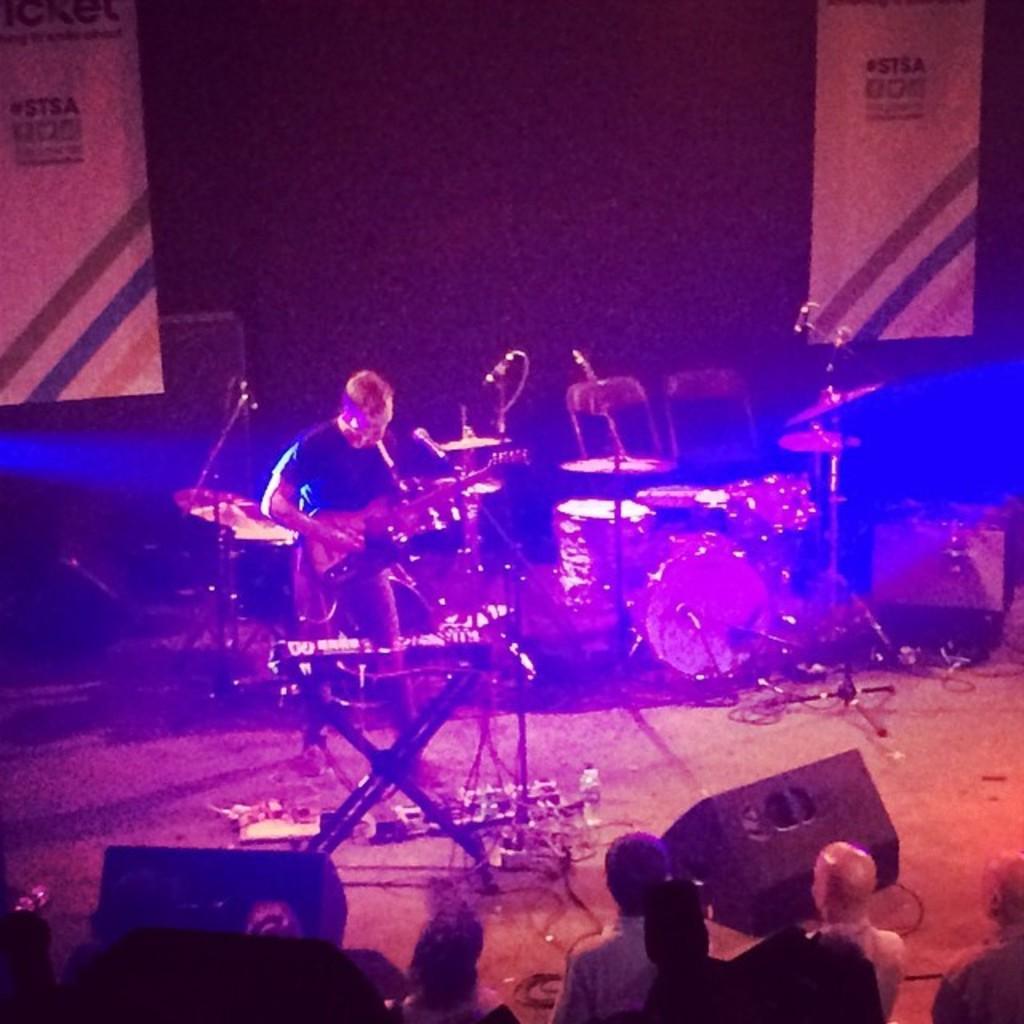Please provide a concise description of this image. In this image we can see a few people, among them, one person is paying a guitar, there are some musical instruments, stands, mics and some objects on the stage. 